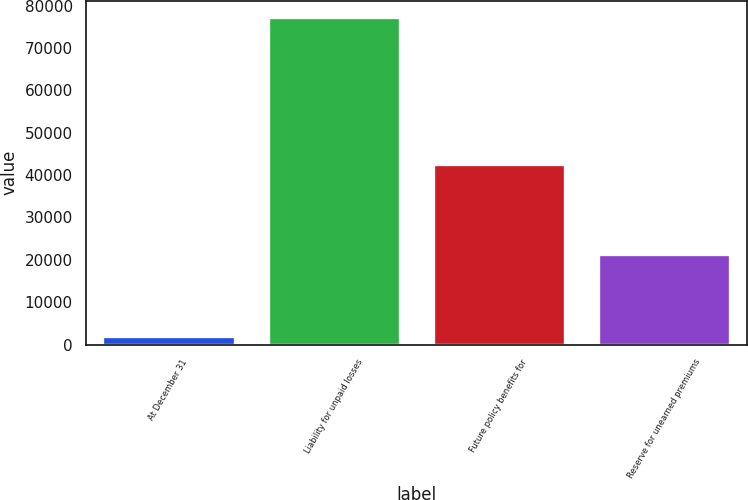Convert chart to OTSL. <chart><loc_0><loc_0><loc_500><loc_500><bar_chart><fcel>At December 31<fcel>Liability for unpaid losses<fcel>Future policy benefits for<fcel>Reserve for unearned premiums<nl><fcel>2014<fcel>77260<fcel>42749<fcel>21324<nl></chart> 